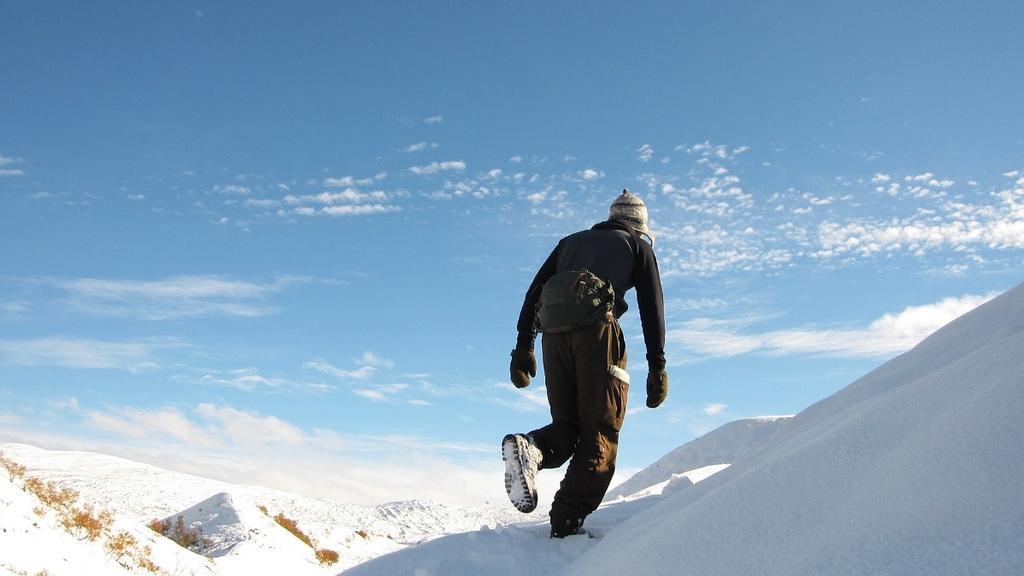Can you describe this image briefly? In this image I can see the person walking on the snow and the person is wearing black color dress. In the background I can see the sky in blue and white color. 